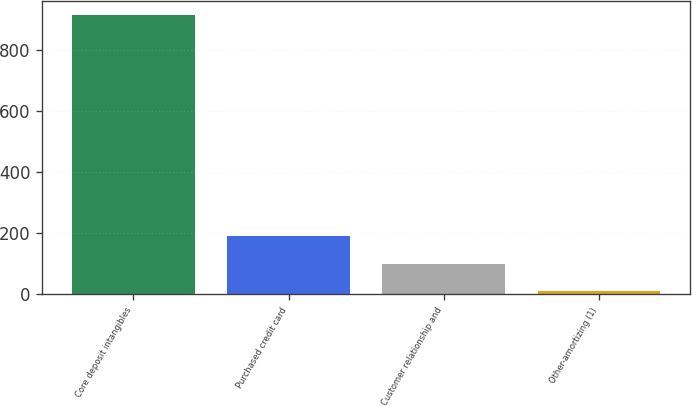Convert chart to OTSL. <chart><loc_0><loc_0><loc_500><loc_500><bar_chart><fcel>Core deposit intangibles<fcel>Purchased credit card<fcel>Customer relationship and<fcel>Other-amortizing (1)<nl><fcel>912<fcel>189.6<fcel>99.3<fcel>9<nl></chart> 